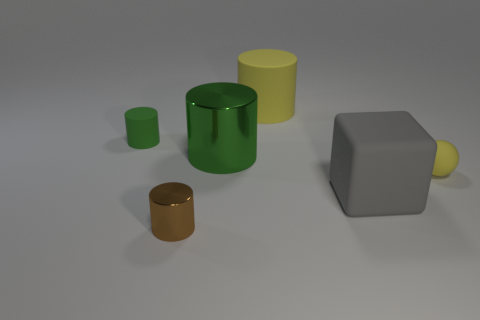Are there any tiny rubber cylinders of the same color as the big rubber block?
Ensure brevity in your answer.  No. What number of big things are either blocks or brown cylinders?
Your answer should be compact. 1. Is the material of the small cylinder that is behind the large rubber block the same as the yellow cylinder?
Offer a very short reply. Yes. There is a big object that is in front of the tiny matte object in front of the rubber cylinder that is left of the yellow cylinder; what shape is it?
Offer a terse response. Cube. How many gray objects are either small matte spheres or large things?
Your answer should be very brief. 1. Are there the same number of green things to the left of the small brown metallic object and small green cylinders that are left of the big gray rubber thing?
Your answer should be compact. Yes. There is a metal object that is in front of the gray matte object; does it have the same shape as the big matte object in front of the small yellow sphere?
Keep it short and to the point. No. Is there any other thing that has the same shape as the big green thing?
Give a very brief answer. Yes. What is the shape of the tiny yellow object that is the same material as the small green cylinder?
Provide a succinct answer. Sphere. Is the number of large objects to the left of the big rubber cube the same as the number of yellow rubber cylinders?
Your response must be concise. No. 